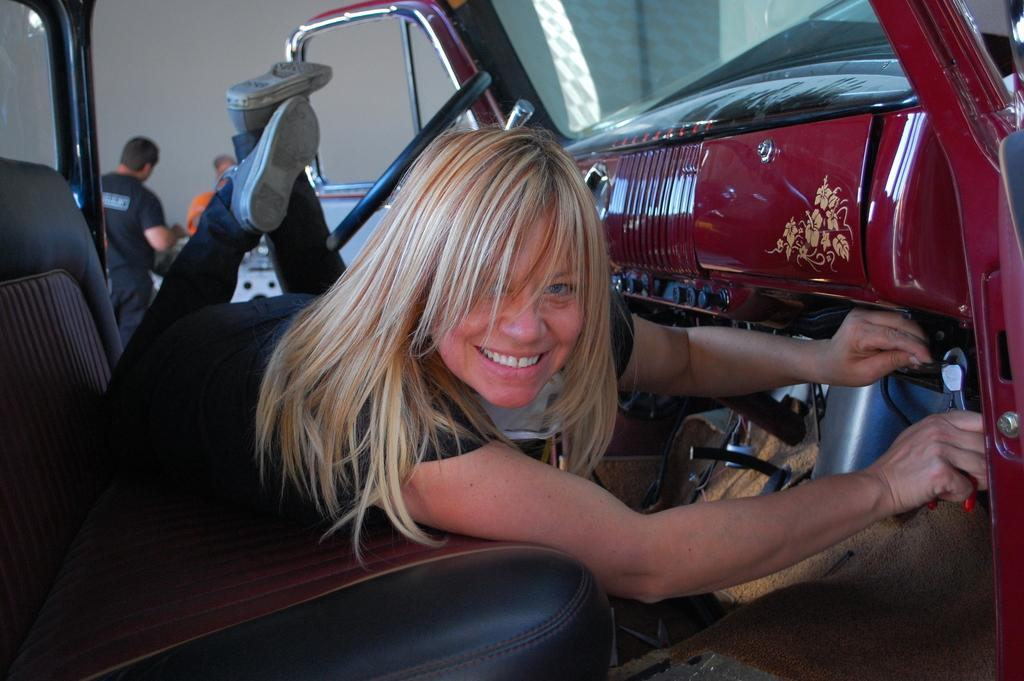How many people are in the image? There are three persons in the image. What is the position and expression of the person inside the car? One person is lying inside the car and smiling. What are the other two persons doing in the image? The two other persons are standing behind the car. What type of plants can be seen growing in the patch behind the car? There are no plants or patches visible in the image; it only features three persons and a car. 